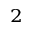Convert formula to latex. <formula><loc_0><loc_0><loc_500><loc_500>_ { 2 }</formula> 